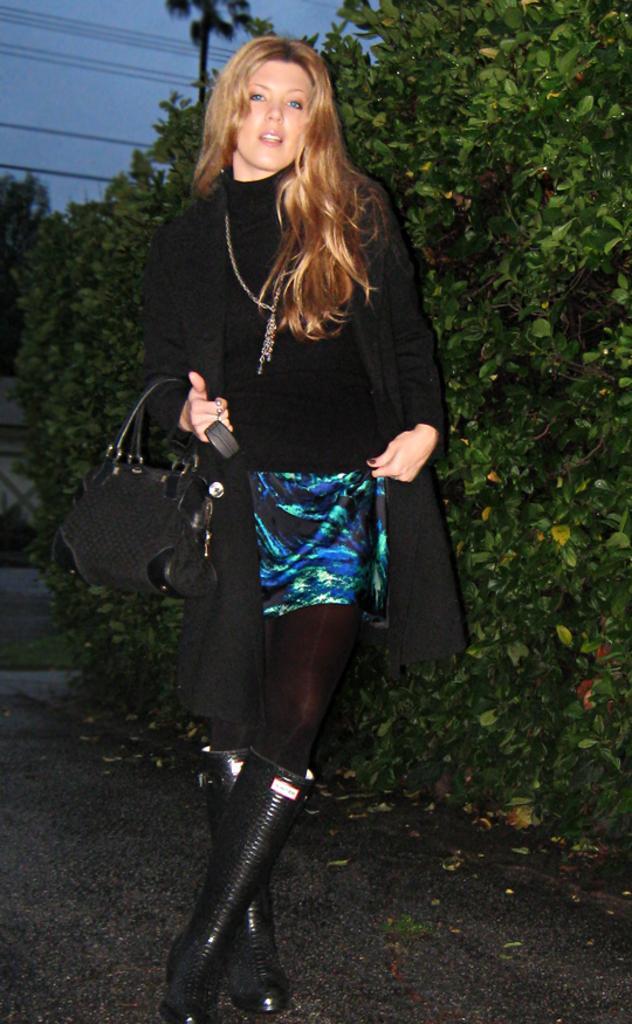Could you give a brief overview of what you see in this image? In this picture i could see a woman dressed for a party holding a bag, in the background i could see green bushes and trees and some cables running along. 